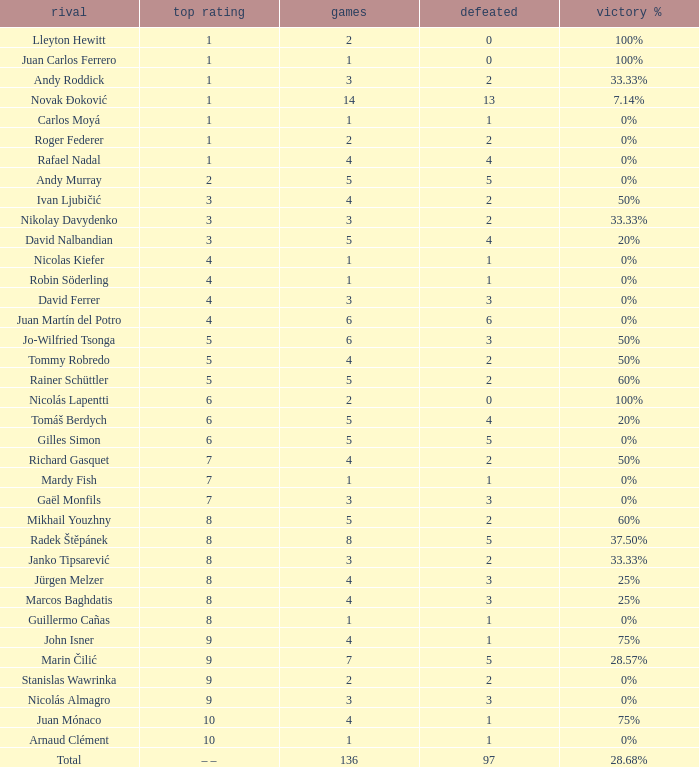What is the smallest number of Matches with less than 97 losses and a Win rate of 28.68%? None. 